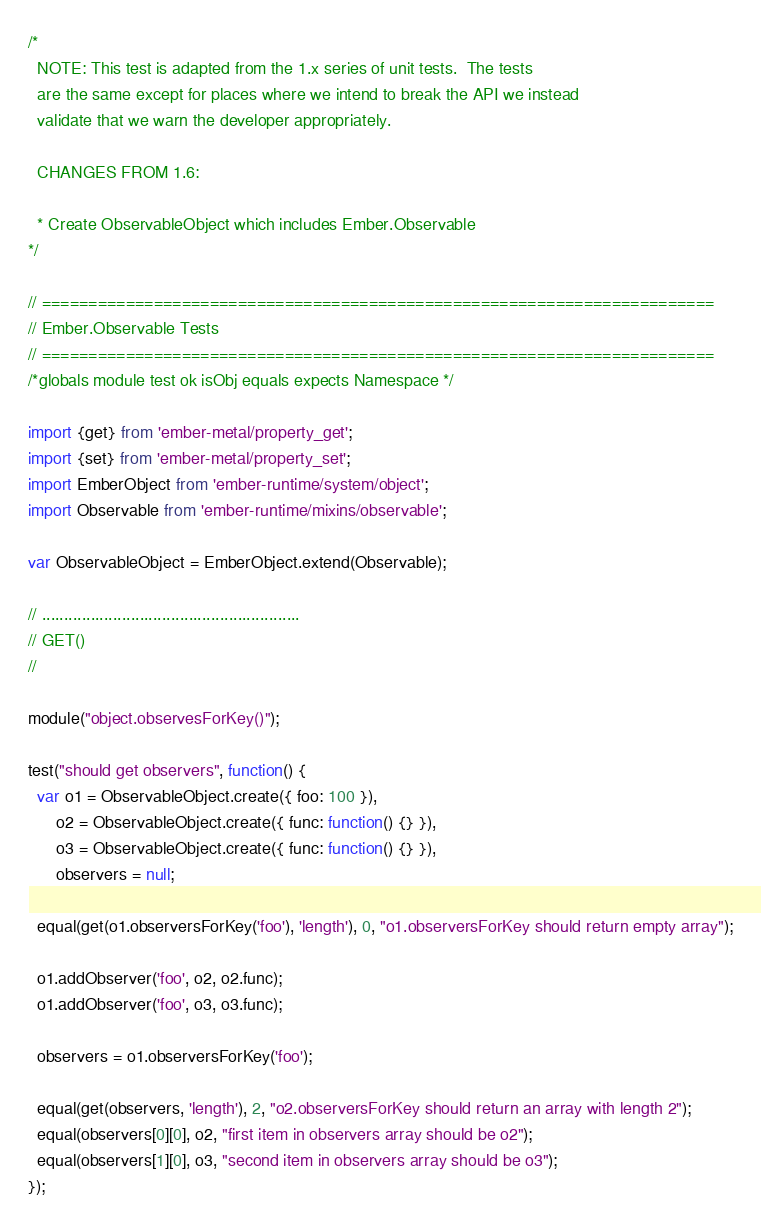Convert code to text. <code><loc_0><loc_0><loc_500><loc_500><_JavaScript_>/*
  NOTE: This test is adapted from the 1.x series of unit tests.  The tests
  are the same except for places where we intend to break the API we instead
  validate that we warn the developer appropriately.

  CHANGES FROM 1.6:

  * Create ObservableObject which includes Ember.Observable
*/

// ========================================================================
// Ember.Observable Tests
// ========================================================================
/*globals module test ok isObj equals expects Namespace */

import {get} from 'ember-metal/property_get';
import {set} from 'ember-metal/property_set';
import EmberObject from 'ember-runtime/system/object';
import Observable from 'ember-runtime/mixins/observable';

var ObservableObject = EmberObject.extend(Observable);

// ..........................................................
// GET()
//

module("object.observesForKey()");

test("should get observers", function() {
  var o1 = ObservableObject.create({ foo: 100 }),
      o2 = ObservableObject.create({ func: function() {} }),
      o3 = ObservableObject.create({ func: function() {} }),
      observers = null;

  equal(get(o1.observersForKey('foo'), 'length'), 0, "o1.observersForKey should return empty array");

  o1.addObserver('foo', o2, o2.func);
  o1.addObserver('foo', o3, o3.func);

  observers = o1.observersForKey('foo');

  equal(get(observers, 'length'), 2, "o2.observersForKey should return an array with length 2");
  equal(observers[0][0], o2, "first item in observers array should be o2");
  equal(observers[1][0], o3, "second item in observers array should be o3");
});
</code> 